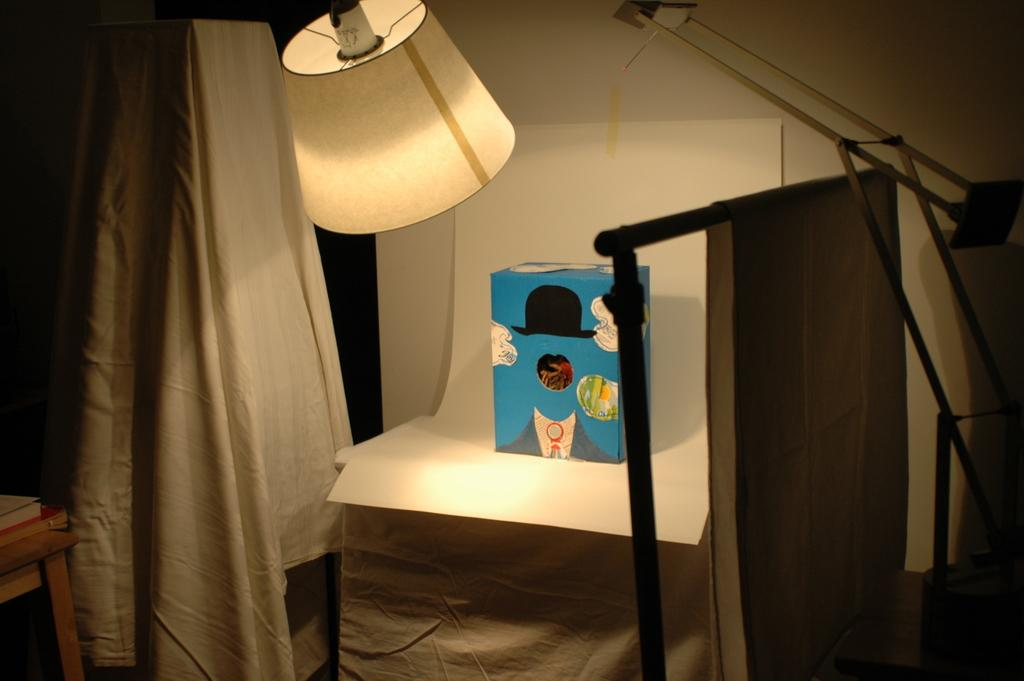What is placed on the paper in the image? There is a box on the paper in the image. What type of items can be seen in the image besides the box? There are clothes and a lamp visible in the image. Where are the books located in the image? The books are on a stool in the image. What can be seen in the background of the image? There is a wall in the background of the image. What type of sky can be seen through the window in the image? There is no window or sky visible in the image. 